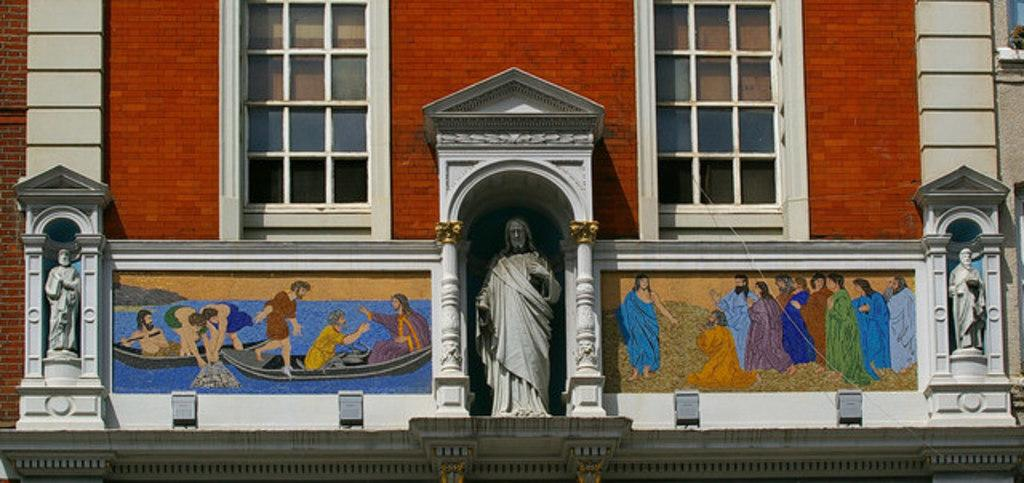What type of structure is present in the image? There is a building in the picture. What feature can be observed on the building? The building has windows. What additional objects are in the image? There are statues in the picture. Can you describe the artwork in the image? There is a wall with a painting in the picture. How does the dust accumulate on the statues in the image? There is no dust present in the image, as it only features a building, windows, statues, and a wall with a painting. What type of vein can be seen in the painting in the image? There is no vein visible in the painting in the image, as the painting's details are not described in the provided facts. 